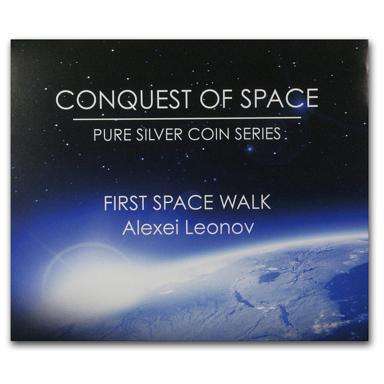Besides Alexei Leonov's spacewalk, what other events are honored in the 'Conquest of Space' series? While the series features numerous pivotal moments, some examples include the launch of the first artificial satellite, Sputnik; the first manned lunar landing by the Apollo 11 crew; and significant space missions such as the deployment of the Hubble Space Telescope. Each coin represents a historical chapter in our pursuit of cosmic knowledge and the unrelenting spirit of human curiosity. 